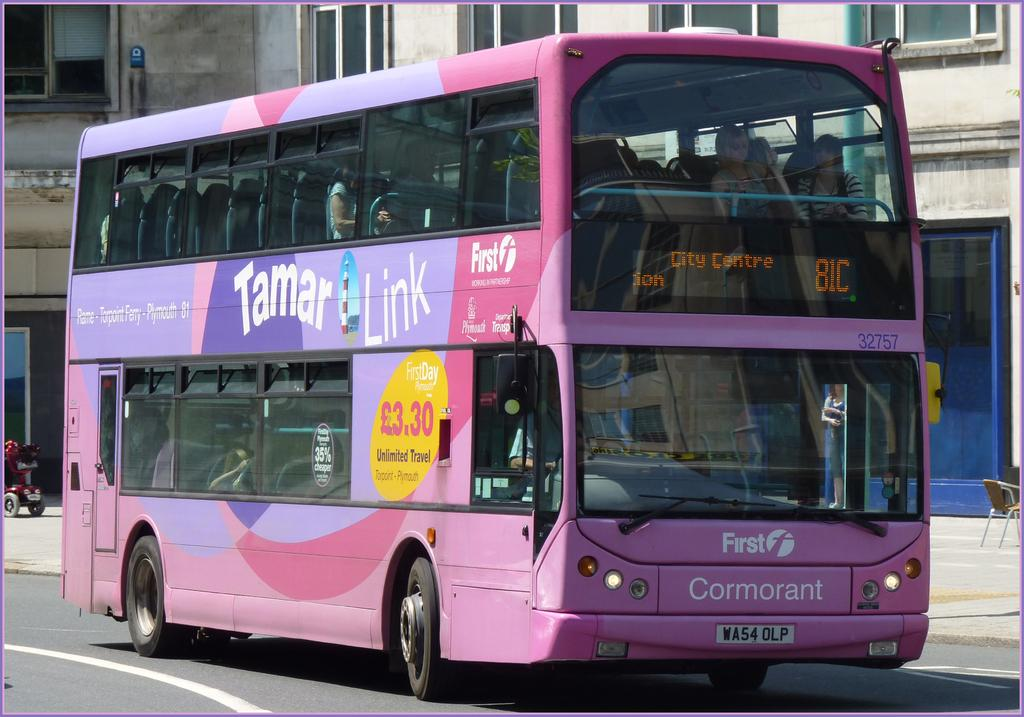What type of vehicle is on the road in the image? There is a bus on a road in the image. What can be seen in the background of the image? There is a pavement and a building in the background of the image. What is on the pavement in the image? There is a chair and a van on the pavement. How much money is being exchanged between the bus and the van in the image? There is no indication of money being exchanged between the bus and the van in the image. 